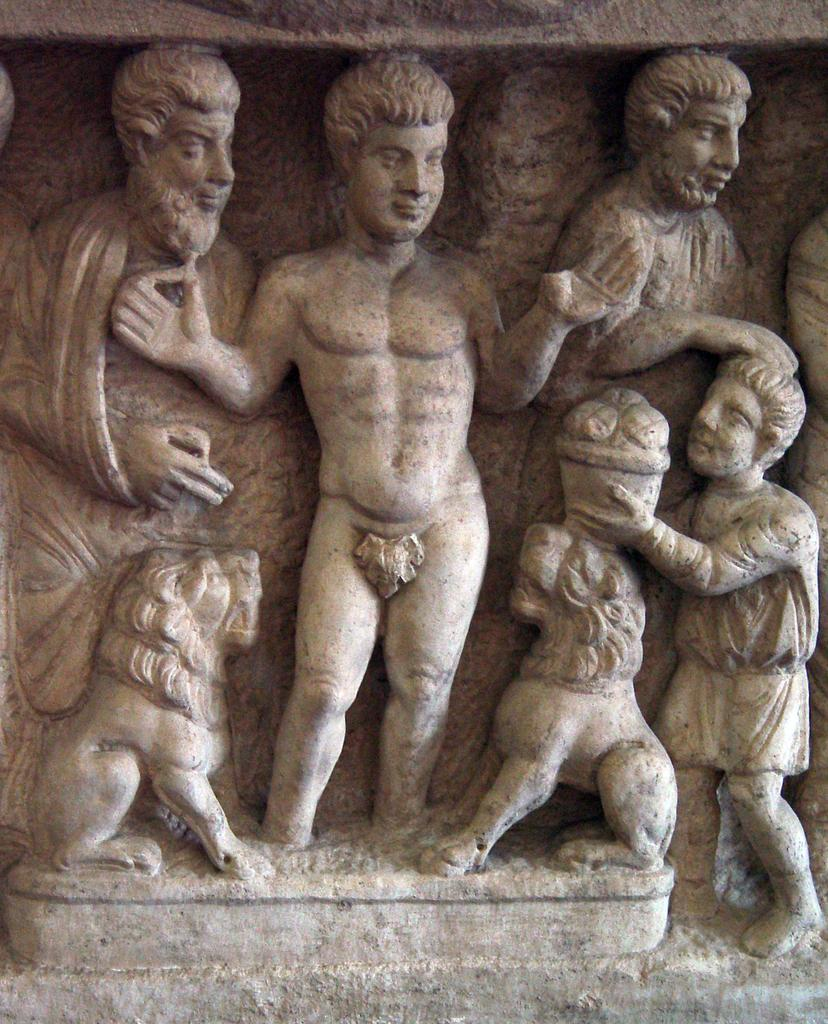What type of objects are depicted in the image? There are statues of people in the image. What color are the statues? The statues are in grey color. Can you describe any other elements in the image besides the statues? There are two animals visible in the image. What time of day is it in the image, and how can you tell? The time of day cannot be determined from the image, as there are no clues or indicators of the time. 